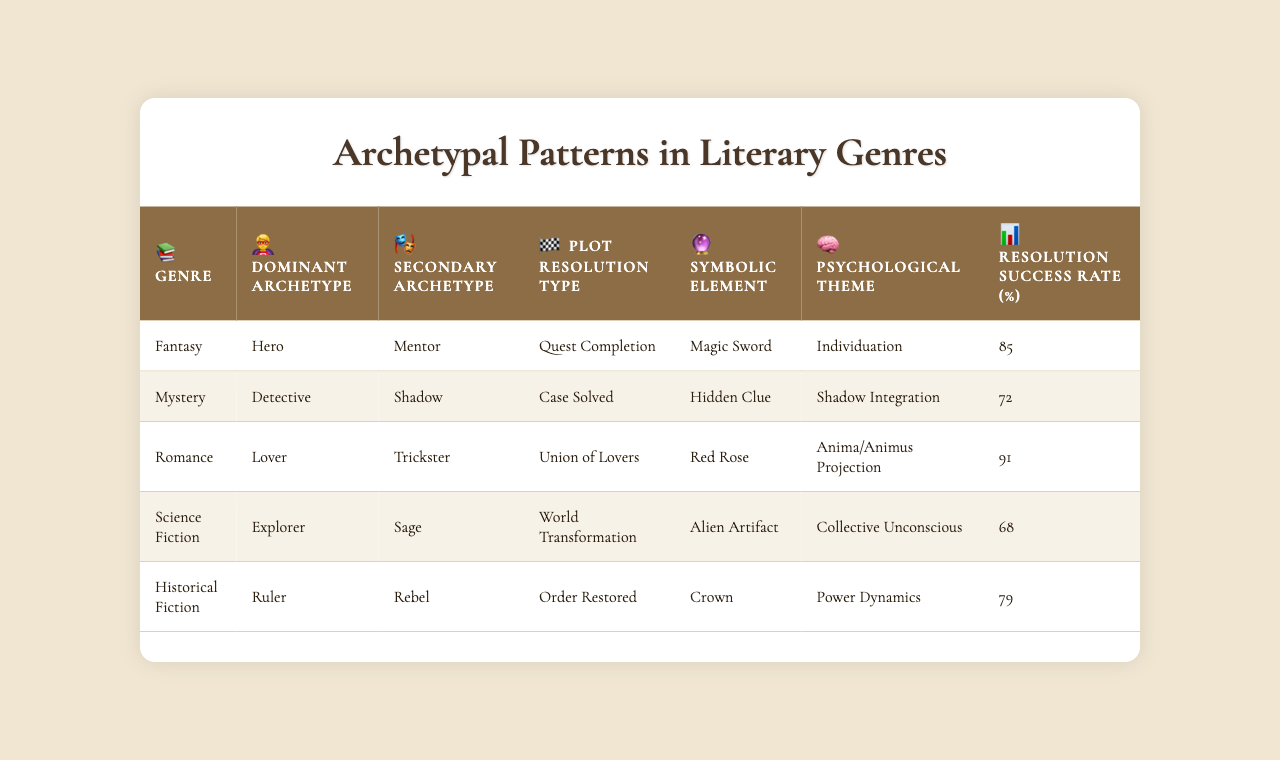What is the dominant archetype in the Fantasy genre? According to the table, the dominant archetype listed for the Fantasy genre is "Hero."
Answer: Hero Which genre has the highest resolution success rate? The table indicates that Romance has the highest resolution success rate at 91%.
Answer: Romance Is there a correlation between the dominant archetype and the plot resolution type? Based on the table, every genre has a defined dominant archetype associated with a specific plot resolution type, suggesting a correlation.
Answer: Yes What is the psychological theme associated with Science Fiction? The table shows that the psychological theme for Science Fiction is "Collective Unconscious."
Answer: Collective Unconscious Calculate the average resolution success rate of all genres. To find the average: (85 + 72 + 91 + 68 + 79) = 395. Since there are 5 genres, average = 395 / 5 = 79.
Answer: 79 What symbolic element is associated with the Mystery genre? The table reveals that the symbolic element for the Mystery genre is "Hidden Clue."
Answer: Hidden Clue Does the Historical Fiction genre have a lower or higher success rate than the Science Fiction genre? The Historical Fiction genre has a success rate of 79% while Science Fiction has 68%. This means it is higher.
Answer: Higher Which genres feature the character archetype "Explorer"? From the table, only the Science Fiction genre features the "Explorer" archetype.
Answer: Science Fiction What is the symbolic element associated with the dominant archetype "Lover"? According to the table, the symbolic element associated with the "Lover" archetype in Romance is the "Red Rose."
Answer: Red Rose Determine if the genre with the secondary archetype "Trickster" has a higher or lower resolution success rate than the one with "Mentor." The secondary archetype "Trickster" is linked to the Mystery genre (72%) while "Mentor" is linked to Fantasy (85%). 72% is lower than 85%.
Answer: Lower 